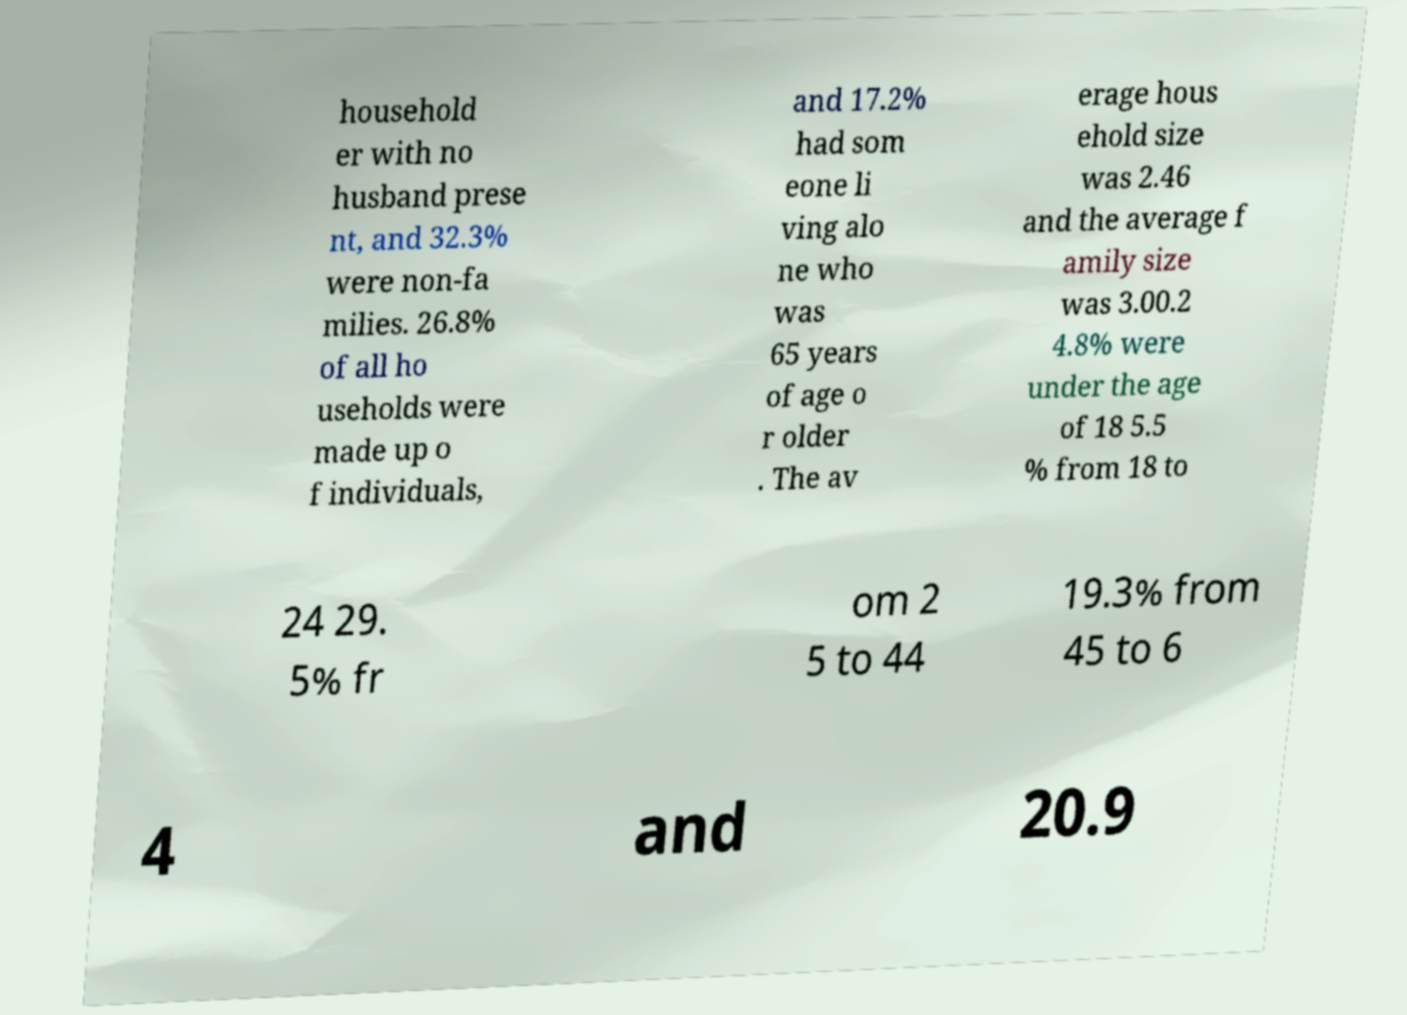I need the written content from this picture converted into text. Can you do that? household er with no husband prese nt, and 32.3% were non-fa milies. 26.8% of all ho useholds were made up o f individuals, and 17.2% had som eone li ving alo ne who was 65 years of age o r older . The av erage hous ehold size was 2.46 and the average f amily size was 3.00.2 4.8% were under the age of 18 5.5 % from 18 to 24 29. 5% fr om 2 5 to 44 19.3% from 45 to 6 4 and 20.9 